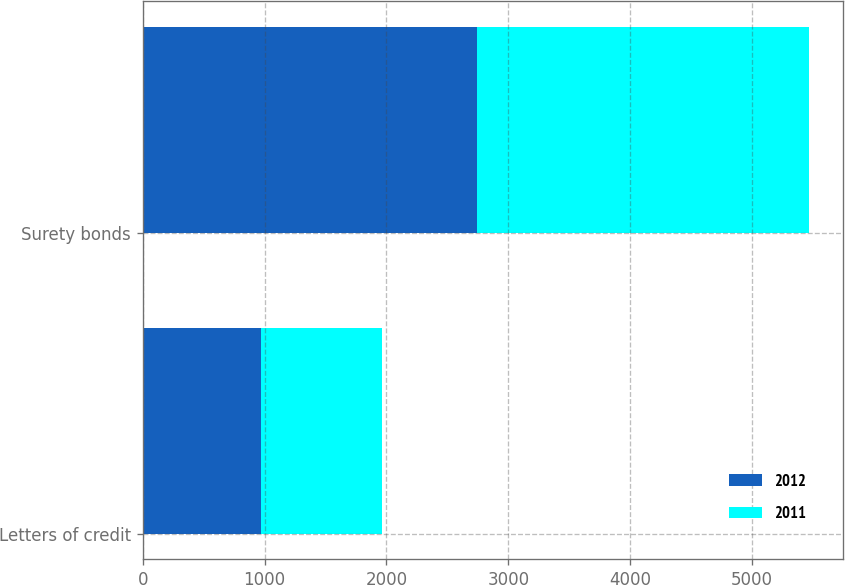<chart> <loc_0><loc_0><loc_500><loc_500><stacked_bar_chart><ecel><fcel>Letters of credit<fcel>Surety bonds<nl><fcel>2012<fcel>972<fcel>2741.5<nl><fcel>2011<fcel>987.8<fcel>2728.2<nl></chart> 